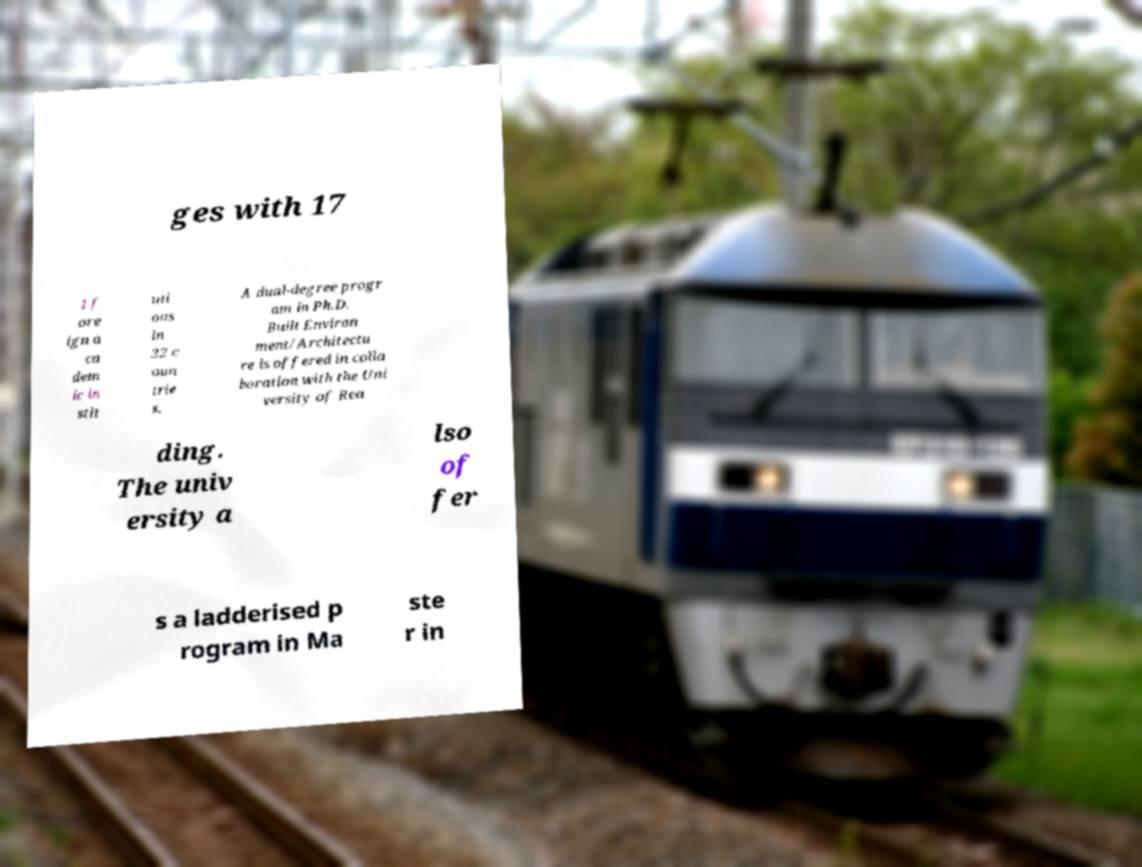What messages or text are displayed in this image? I need them in a readable, typed format. ges with 17 1 f ore ign a ca dem ic in stit uti ons in 32 c oun trie s. A dual-degree progr am in Ph.D. Built Environ ment/Architectu re is offered in colla boration with the Uni versity of Rea ding. The univ ersity a lso of fer s a ladderised p rogram in Ma ste r in 